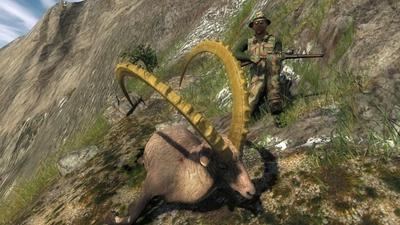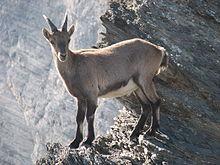The first image is the image on the left, the second image is the image on the right. For the images displayed, is the sentence "The sky can be seen in the image on the right." factually correct? Answer yes or no. No. 